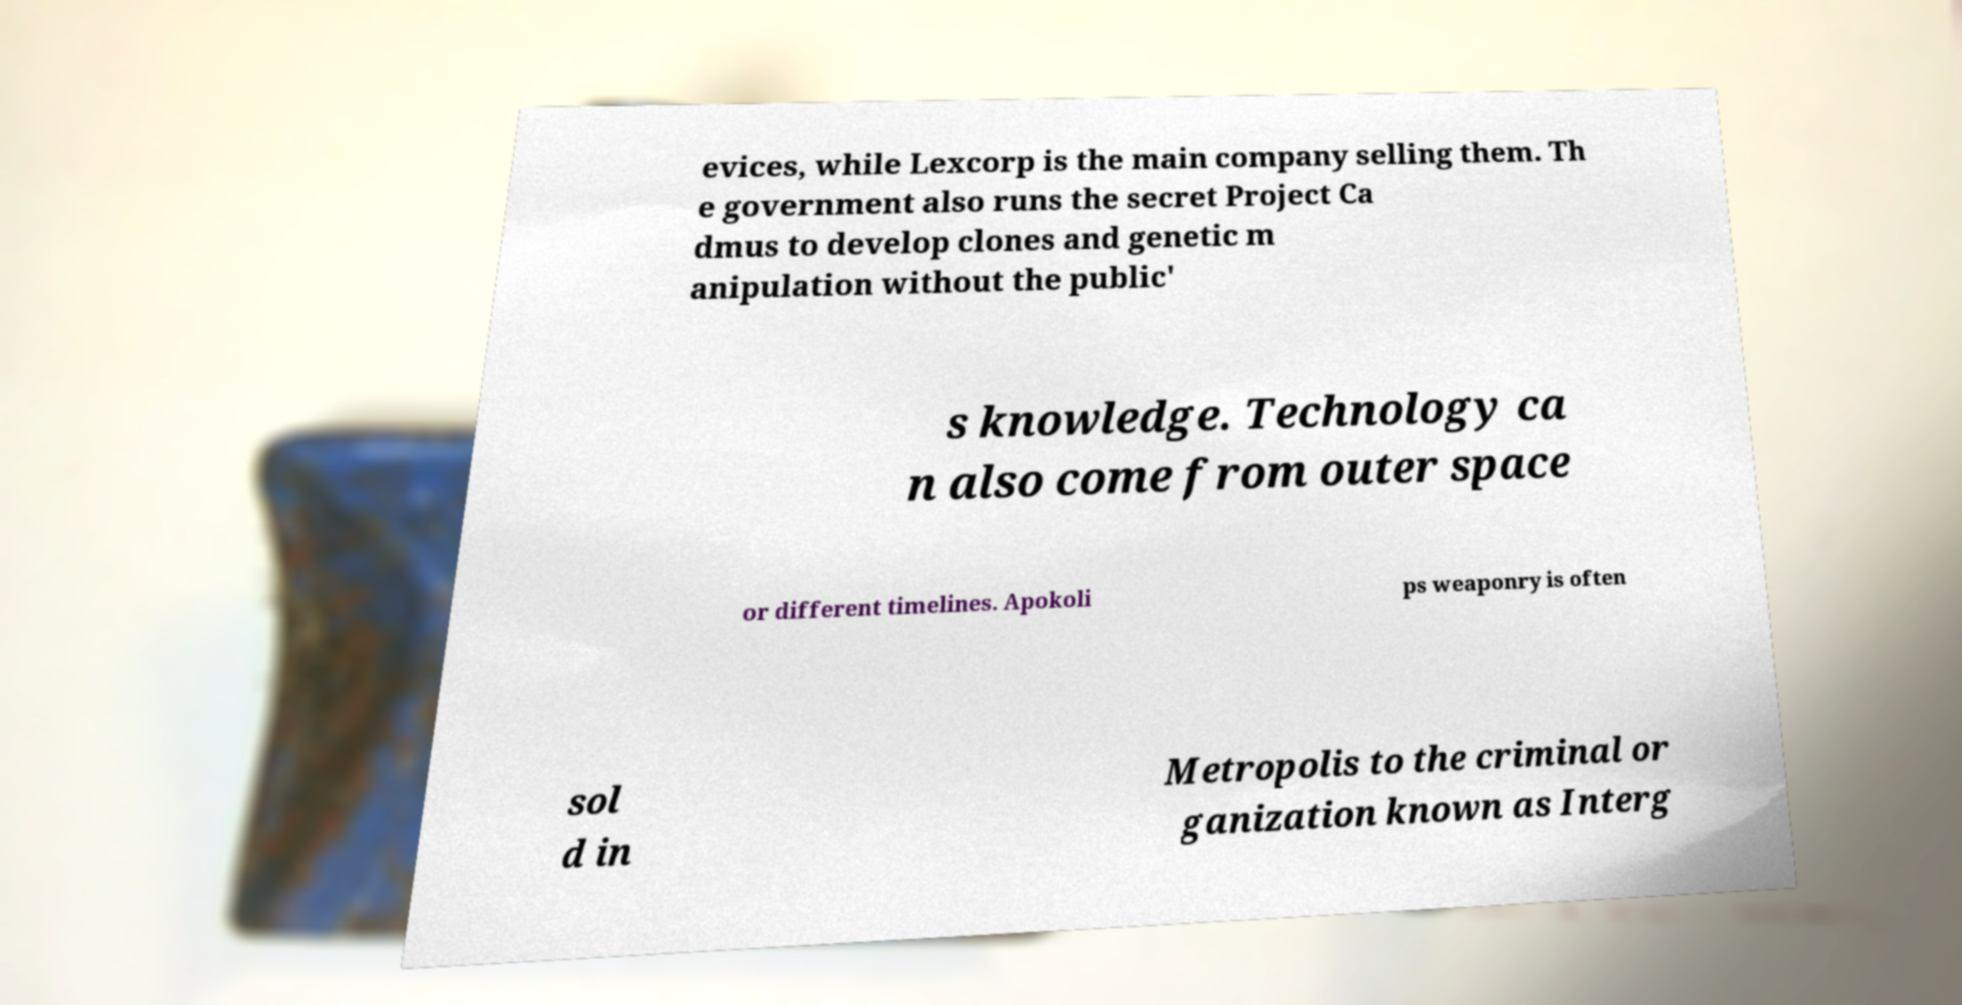Can you accurately transcribe the text from the provided image for me? evices, while Lexcorp is the main company selling them. Th e government also runs the secret Project Ca dmus to develop clones and genetic m anipulation without the public' s knowledge. Technology ca n also come from outer space or different timelines. Apokoli ps weaponry is often sol d in Metropolis to the criminal or ganization known as Interg 